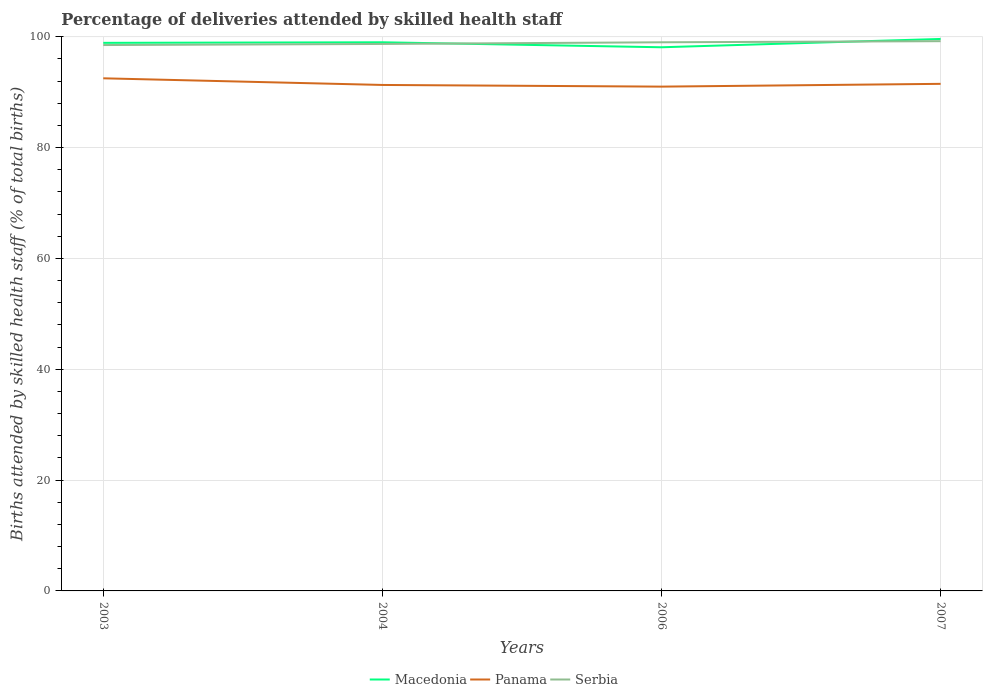How many different coloured lines are there?
Make the answer very short. 3. Across all years, what is the maximum percentage of births attended by skilled health staff in Serbia?
Your answer should be very brief. 98.5. In which year was the percentage of births attended by skilled health staff in Panama maximum?
Offer a terse response. 2006. What is the difference between the highest and the lowest percentage of births attended by skilled health staff in Serbia?
Offer a terse response. 2. How many lines are there?
Offer a terse response. 3. How many years are there in the graph?
Ensure brevity in your answer.  4. What is the difference between two consecutive major ticks on the Y-axis?
Ensure brevity in your answer.  20. Are the values on the major ticks of Y-axis written in scientific E-notation?
Provide a short and direct response. No. Does the graph contain any zero values?
Offer a very short reply. No. Where does the legend appear in the graph?
Give a very brief answer. Bottom center. What is the title of the graph?
Keep it short and to the point. Percentage of deliveries attended by skilled health staff. What is the label or title of the Y-axis?
Make the answer very short. Births attended by skilled health staff (% of total births). What is the Births attended by skilled health staff (% of total births) of Macedonia in 2003?
Your answer should be very brief. 98.9. What is the Births attended by skilled health staff (% of total births) in Panama in 2003?
Your answer should be compact. 92.5. What is the Births attended by skilled health staff (% of total births) in Serbia in 2003?
Ensure brevity in your answer.  98.5. What is the Births attended by skilled health staff (% of total births) of Macedonia in 2004?
Offer a very short reply. 99. What is the Births attended by skilled health staff (% of total births) of Panama in 2004?
Provide a succinct answer. 91.3. What is the Births attended by skilled health staff (% of total births) of Serbia in 2004?
Offer a very short reply. 98.7. What is the Births attended by skilled health staff (% of total births) of Macedonia in 2006?
Offer a terse response. 98.1. What is the Births attended by skilled health staff (% of total births) of Panama in 2006?
Provide a short and direct response. 91. What is the Births attended by skilled health staff (% of total births) of Serbia in 2006?
Keep it short and to the point. 99. What is the Births attended by skilled health staff (% of total births) of Macedonia in 2007?
Your response must be concise. 99.6. What is the Births attended by skilled health staff (% of total births) in Panama in 2007?
Your answer should be very brief. 91.5. What is the Births attended by skilled health staff (% of total births) of Serbia in 2007?
Keep it short and to the point. 99.2. Across all years, what is the maximum Births attended by skilled health staff (% of total births) of Macedonia?
Your answer should be very brief. 99.6. Across all years, what is the maximum Births attended by skilled health staff (% of total births) in Panama?
Your answer should be compact. 92.5. Across all years, what is the maximum Births attended by skilled health staff (% of total births) of Serbia?
Offer a terse response. 99.2. Across all years, what is the minimum Births attended by skilled health staff (% of total births) in Macedonia?
Give a very brief answer. 98.1. Across all years, what is the minimum Births attended by skilled health staff (% of total births) of Panama?
Make the answer very short. 91. Across all years, what is the minimum Births attended by skilled health staff (% of total births) of Serbia?
Your answer should be very brief. 98.5. What is the total Births attended by skilled health staff (% of total births) of Macedonia in the graph?
Offer a very short reply. 395.6. What is the total Births attended by skilled health staff (% of total births) in Panama in the graph?
Your answer should be compact. 366.3. What is the total Births attended by skilled health staff (% of total births) of Serbia in the graph?
Make the answer very short. 395.4. What is the difference between the Births attended by skilled health staff (% of total births) of Macedonia in 2003 and that in 2004?
Provide a succinct answer. -0.1. What is the difference between the Births attended by skilled health staff (% of total births) of Panama in 2003 and that in 2004?
Ensure brevity in your answer.  1.2. What is the difference between the Births attended by skilled health staff (% of total births) in Serbia in 2003 and that in 2004?
Make the answer very short. -0.2. What is the difference between the Births attended by skilled health staff (% of total births) of Macedonia in 2003 and that in 2006?
Your answer should be very brief. 0.8. What is the difference between the Births attended by skilled health staff (% of total births) of Panama in 2003 and that in 2006?
Provide a succinct answer. 1.5. What is the difference between the Births attended by skilled health staff (% of total births) of Macedonia in 2003 and that in 2007?
Offer a terse response. -0.7. What is the difference between the Births attended by skilled health staff (% of total births) in Serbia in 2003 and that in 2007?
Offer a terse response. -0.7. What is the difference between the Births attended by skilled health staff (% of total births) of Macedonia in 2004 and that in 2006?
Give a very brief answer. 0.9. What is the difference between the Births attended by skilled health staff (% of total births) of Serbia in 2004 and that in 2006?
Make the answer very short. -0.3. What is the difference between the Births attended by skilled health staff (% of total births) in Macedonia in 2004 and that in 2007?
Give a very brief answer. -0.6. What is the difference between the Births attended by skilled health staff (% of total births) of Serbia in 2004 and that in 2007?
Your answer should be compact. -0.5. What is the difference between the Births attended by skilled health staff (% of total births) of Macedonia in 2006 and that in 2007?
Your response must be concise. -1.5. What is the difference between the Births attended by skilled health staff (% of total births) of Panama in 2006 and that in 2007?
Your answer should be very brief. -0.5. What is the difference between the Births attended by skilled health staff (% of total births) in Macedonia in 2003 and the Births attended by skilled health staff (% of total births) in Panama in 2004?
Your answer should be compact. 7.6. What is the difference between the Births attended by skilled health staff (% of total births) in Panama in 2003 and the Births attended by skilled health staff (% of total births) in Serbia in 2004?
Offer a very short reply. -6.2. What is the difference between the Births attended by skilled health staff (% of total births) in Macedonia in 2003 and the Births attended by skilled health staff (% of total births) in Panama in 2006?
Offer a very short reply. 7.9. What is the difference between the Births attended by skilled health staff (% of total births) in Macedonia in 2003 and the Births attended by skilled health staff (% of total births) in Panama in 2007?
Provide a succinct answer. 7.4. What is the difference between the Births attended by skilled health staff (% of total births) of Macedonia in 2003 and the Births attended by skilled health staff (% of total births) of Serbia in 2007?
Offer a very short reply. -0.3. What is the difference between the Births attended by skilled health staff (% of total births) in Macedonia in 2004 and the Births attended by skilled health staff (% of total births) in Panama in 2006?
Your answer should be very brief. 8. What is the difference between the Births attended by skilled health staff (% of total births) in Macedonia in 2004 and the Births attended by skilled health staff (% of total births) in Serbia in 2006?
Your answer should be very brief. 0. What is the difference between the Births attended by skilled health staff (% of total births) of Panama in 2004 and the Births attended by skilled health staff (% of total births) of Serbia in 2006?
Give a very brief answer. -7.7. What is the difference between the Births attended by skilled health staff (% of total births) in Macedonia in 2006 and the Births attended by skilled health staff (% of total births) in Panama in 2007?
Your answer should be very brief. 6.6. What is the difference between the Births attended by skilled health staff (% of total births) of Macedonia in 2006 and the Births attended by skilled health staff (% of total births) of Serbia in 2007?
Provide a succinct answer. -1.1. What is the difference between the Births attended by skilled health staff (% of total births) of Panama in 2006 and the Births attended by skilled health staff (% of total births) of Serbia in 2007?
Ensure brevity in your answer.  -8.2. What is the average Births attended by skilled health staff (% of total births) in Macedonia per year?
Your response must be concise. 98.9. What is the average Births attended by skilled health staff (% of total births) in Panama per year?
Provide a succinct answer. 91.58. What is the average Births attended by skilled health staff (% of total births) in Serbia per year?
Offer a very short reply. 98.85. In the year 2003, what is the difference between the Births attended by skilled health staff (% of total births) of Panama and Births attended by skilled health staff (% of total births) of Serbia?
Provide a succinct answer. -6. In the year 2004, what is the difference between the Births attended by skilled health staff (% of total births) in Macedonia and Births attended by skilled health staff (% of total births) in Serbia?
Your answer should be compact. 0.3. In the year 2006, what is the difference between the Births attended by skilled health staff (% of total births) of Macedonia and Births attended by skilled health staff (% of total births) of Serbia?
Your answer should be compact. -0.9. In the year 2006, what is the difference between the Births attended by skilled health staff (% of total births) of Panama and Births attended by skilled health staff (% of total births) of Serbia?
Your response must be concise. -8. In the year 2007, what is the difference between the Births attended by skilled health staff (% of total births) in Panama and Births attended by skilled health staff (% of total births) in Serbia?
Your answer should be compact. -7.7. What is the ratio of the Births attended by skilled health staff (% of total births) in Panama in 2003 to that in 2004?
Provide a short and direct response. 1.01. What is the ratio of the Births attended by skilled health staff (% of total births) in Macedonia in 2003 to that in 2006?
Keep it short and to the point. 1.01. What is the ratio of the Births attended by skilled health staff (% of total births) of Panama in 2003 to that in 2006?
Provide a succinct answer. 1.02. What is the ratio of the Births attended by skilled health staff (% of total births) of Macedonia in 2003 to that in 2007?
Provide a succinct answer. 0.99. What is the ratio of the Births attended by skilled health staff (% of total births) of Panama in 2003 to that in 2007?
Ensure brevity in your answer.  1.01. What is the ratio of the Births attended by skilled health staff (% of total births) in Macedonia in 2004 to that in 2006?
Keep it short and to the point. 1.01. What is the ratio of the Births attended by skilled health staff (% of total births) in Macedonia in 2004 to that in 2007?
Provide a succinct answer. 0.99. What is the ratio of the Births attended by skilled health staff (% of total births) in Panama in 2004 to that in 2007?
Offer a terse response. 1. What is the ratio of the Births attended by skilled health staff (% of total births) in Serbia in 2004 to that in 2007?
Your answer should be very brief. 0.99. What is the ratio of the Births attended by skilled health staff (% of total births) in Macedonia in 2006 to that in 2007?
Keep it short and to the point. 0.98. What is the ratio of the Births attended by skilled health staff (% of total births) in Panama in 2006 to that in 2007?
Offer a terse response. 0.99. What is the difference between the highest and the second highest Births attended by skilled health staff (% of total births) in Panama?
Keep it short and to the point. 1. What is the difference between the highest and the lowest Births attended by skilled health staff (% of total births) in Macedonia?
Your response must be concise. 1.5. What is the difference between the highest and the lowest Births attended by skilled health staff (% of total births) of Serbia?
Provide a succinct answer. 0.7. 